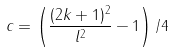Convert formula to latex. <formula><loc_0><loc_0><loc_500><loc_500>c = \left ( \frac { ( 2 k + 1 ) ^ { 2 } } { l ^ { 2 } } - 1 \right ) / 4</formula> 